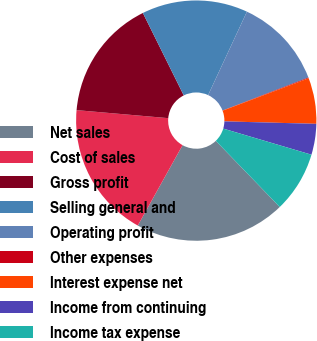<chart> <loc_0><loc_0><loc_500><loc_500><pie_chart><fcel>Net sales<fcel>Cost of sales<fcel>Gross profit<fcel>Selling general and<fcel>Operating profit<fcel>Other expenses<fcel>Interest expense net<fcel>Income from continuing<fcel>Income tax expense<nl><fcel>20.32%<fcel>18.3%<fcel>16.28%<fcel>14.26%<fcel>12.23%<fcel>0.1%<fcel>6.17%<fcel>4.15%<fcel>8.19%<nl></chart> 